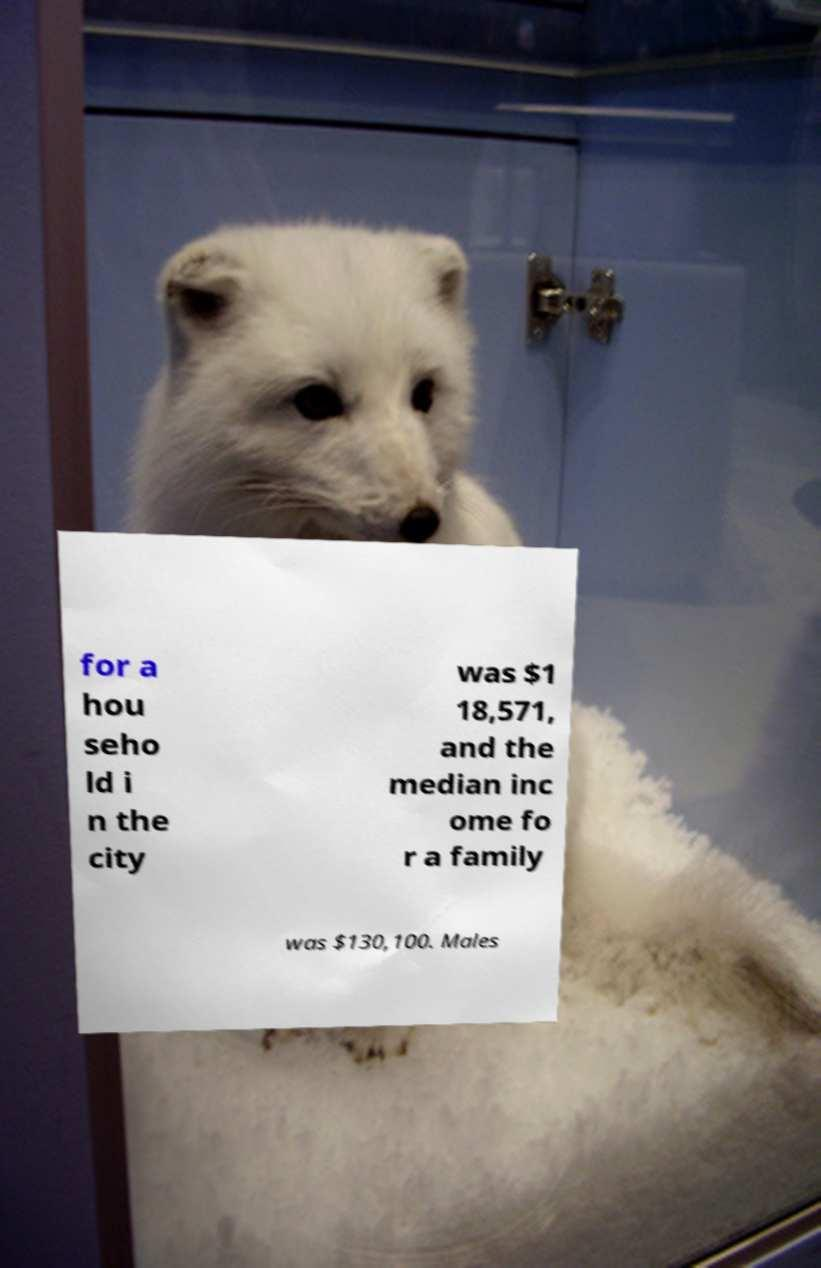Can you accurately transcribe the text from the provided image for me? for a hou seho ld i n the city was $1 18,571, and the median inc ome fo r a family was $130,100. Males 